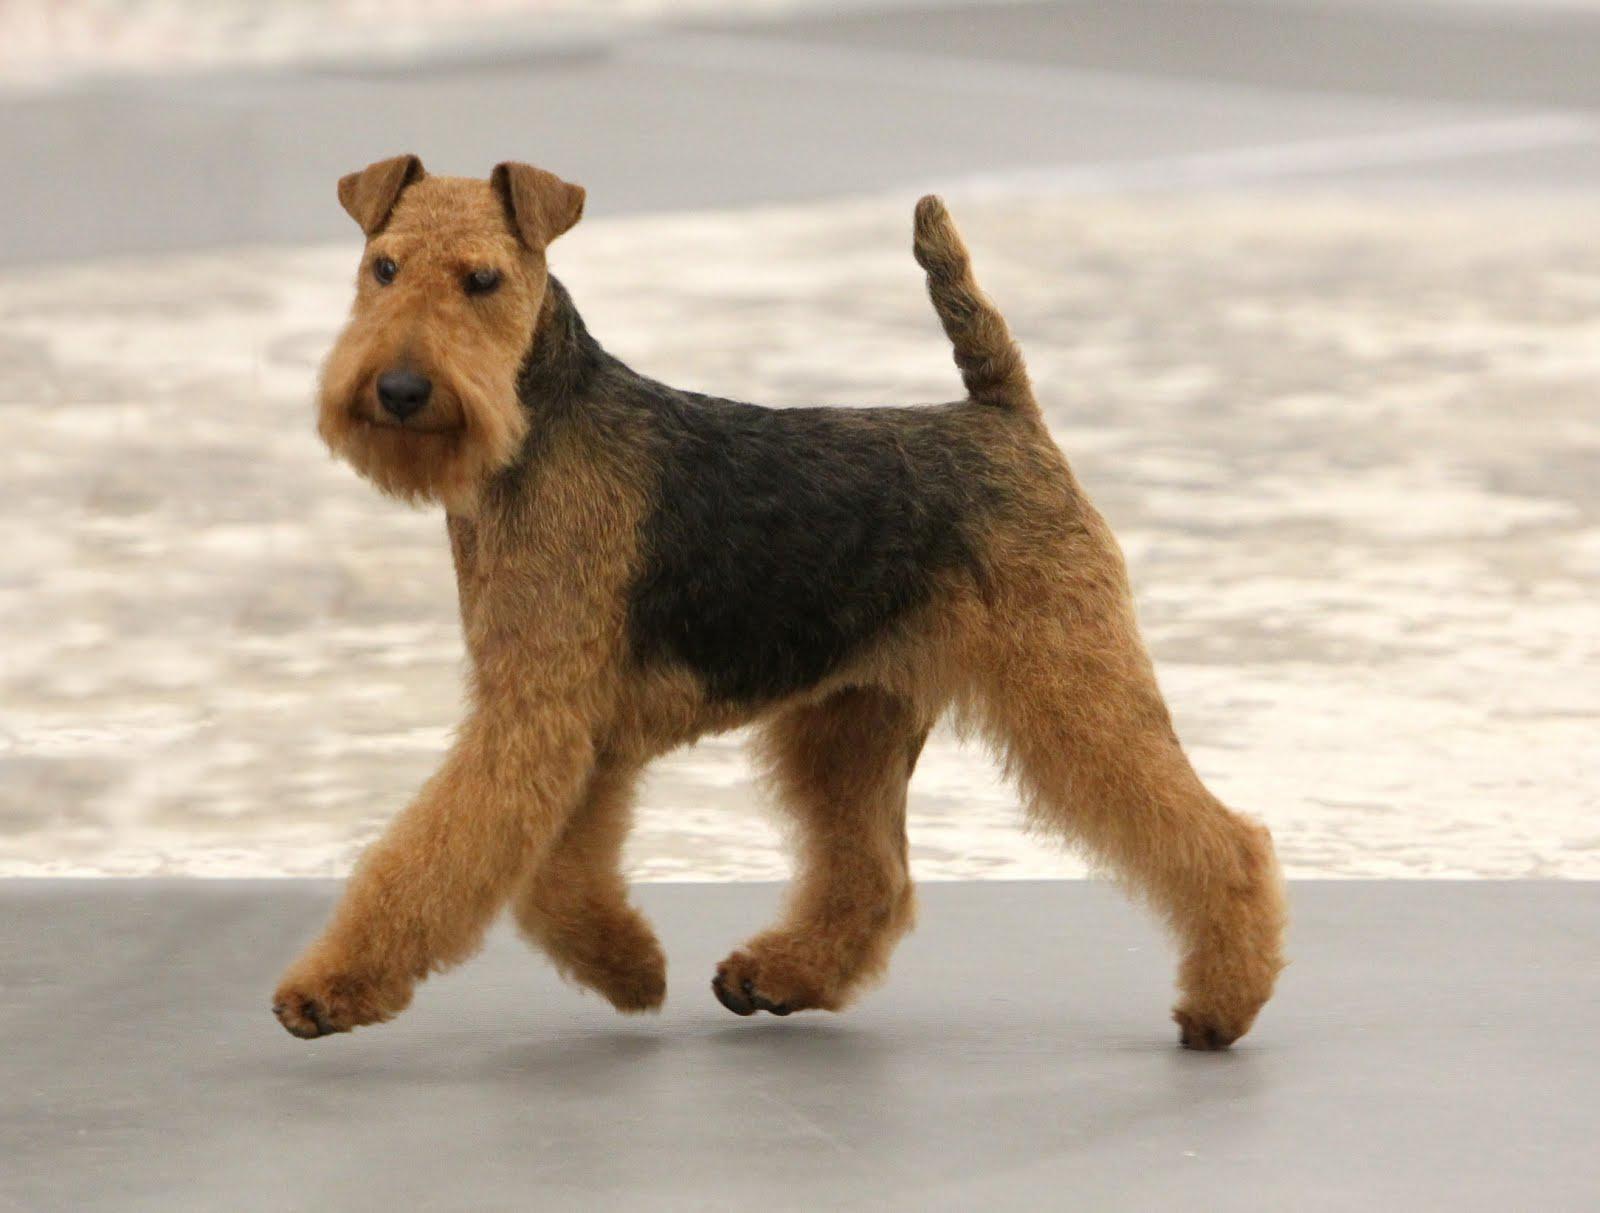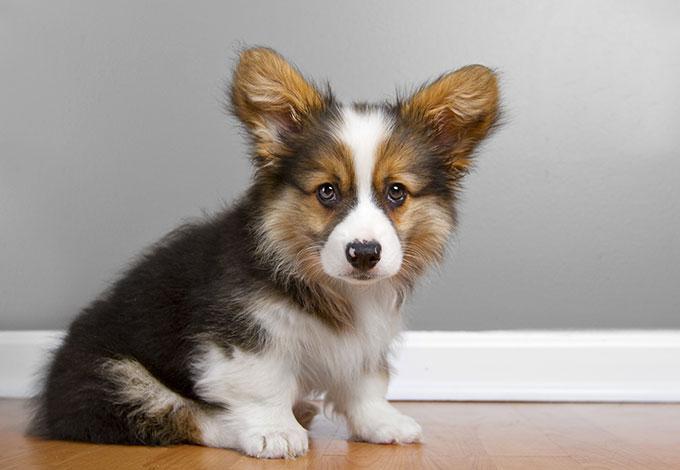The first image is the image on the left, the second image is the image on the right. Assess this claim about the two images: "There are 3 dogs.". Correct or not? Answer yes or no. No. 